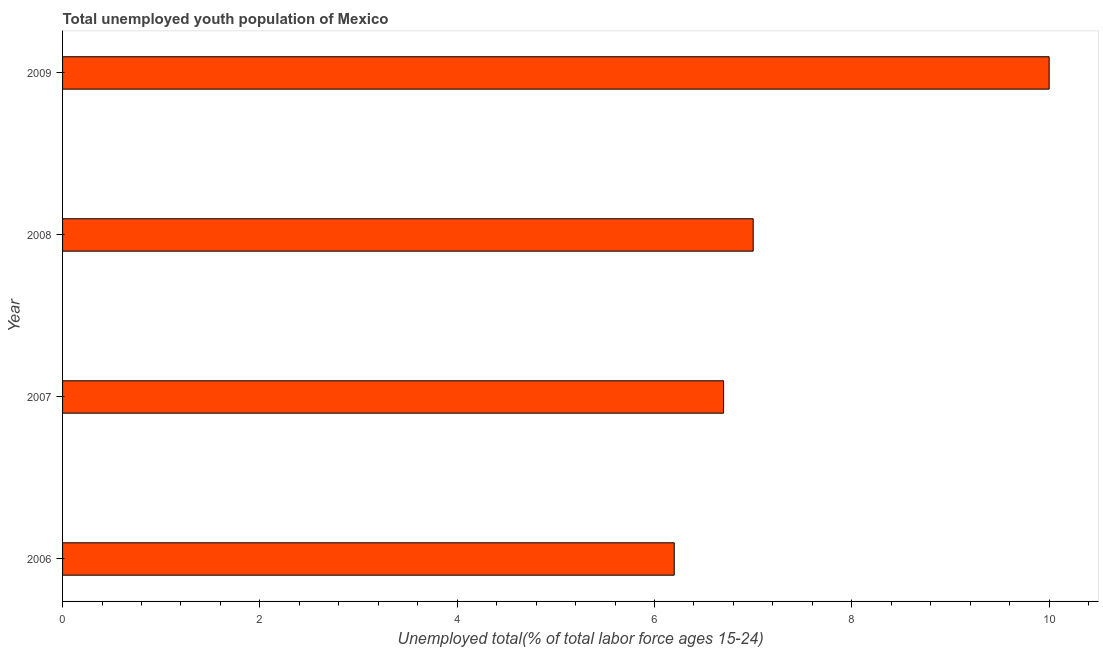Does the graph contain grids?
Your answer should be compact. No. What is the title of the graph?
Your answer should be very brief. Total unemployed youth population of Mexico. What is the label or title of the X-axis?
Give a very brief answer. Unemployed total(% of total labor force ages 15-24). What is the label or title of the Y-axis?
Provide a short and direct response. Year. Across all years, what is the minimum unemployed youth?
Provide a short and direct response. 6.2. In which year was the unemployed youth minimum?
Provide a succinct answer. 2006. What is the sum of the unemployed youth?
Your answer should be compact. 29.9. What is the average unemployed youth per year?
Make the answer very short. 7.47. What is the median unemployed youth?
Your response must be concise. 6.85. Do a majority of the years between 2009 and 2007 (inclusive) have unemployed youth greater than 2 %?
Provide a short and direct response. Yes. Is the difference between the unemployed youth in 2006 and 2007 greater than the difference between any two years?
Your answer should be compact. No. What is the difference between the highest and the second highest unemployed youth?
Keep it short and to the point. 3. How many years are there in the graph?
Give a very brief answer. 4. What is the difference between two consecutive major ticks on the X-axis?
Your answer should be very brief. 2. What is the Unemployed total(% of total labor force ages 15-24) of 2006?
Ensure brevity in your answer.  6.2. What is the Unemployed total(% of total labor force ages 15-24) in 2007?
Offer a very short reply. 6.7. What is the Unemployed total(% of total labor force ages 15-24) in 2008?
Ensure brevity in your answer.  7. What is the Unemployed total(% of total labor force ages 15-24) in 2009?
Offer a terse response. 10. What is the difference between the Unemployed total(% of total labor force ages 15-24) in 2006 and 2007?
Provide a short and direct response. -0.5. What is the difference between the Unemployed total(% of total labor force ages 15-24) in 2007 and 2008?
Give a very brief answer. -0.3. What is the ratio of the Unemployed total(% of total labor force ages 15-24) in 2006 to that in 2007?
Provide a short and direct response. 0.93. What is the ratio of the Unemployed total(% of total labor force ages 15-24) in 2006 to that in 2008?
Offer a very short reply. 0.89. What is the ratio of the Unemployed total(% of total labor force ages 15-24) in 2006 to that in 2009?
Offer a very short reply. 0.62. What is the ratio of the Unemployed total(% of total labor force ages 15-24) in 2007 to that in 2009?
Keep it short and to the point. 0.67. What is the ratio of the Unemployed total(% of total labor force ages 15-24) in 2008 to that in 2009?
Provide a succinct answer. 0.7. 